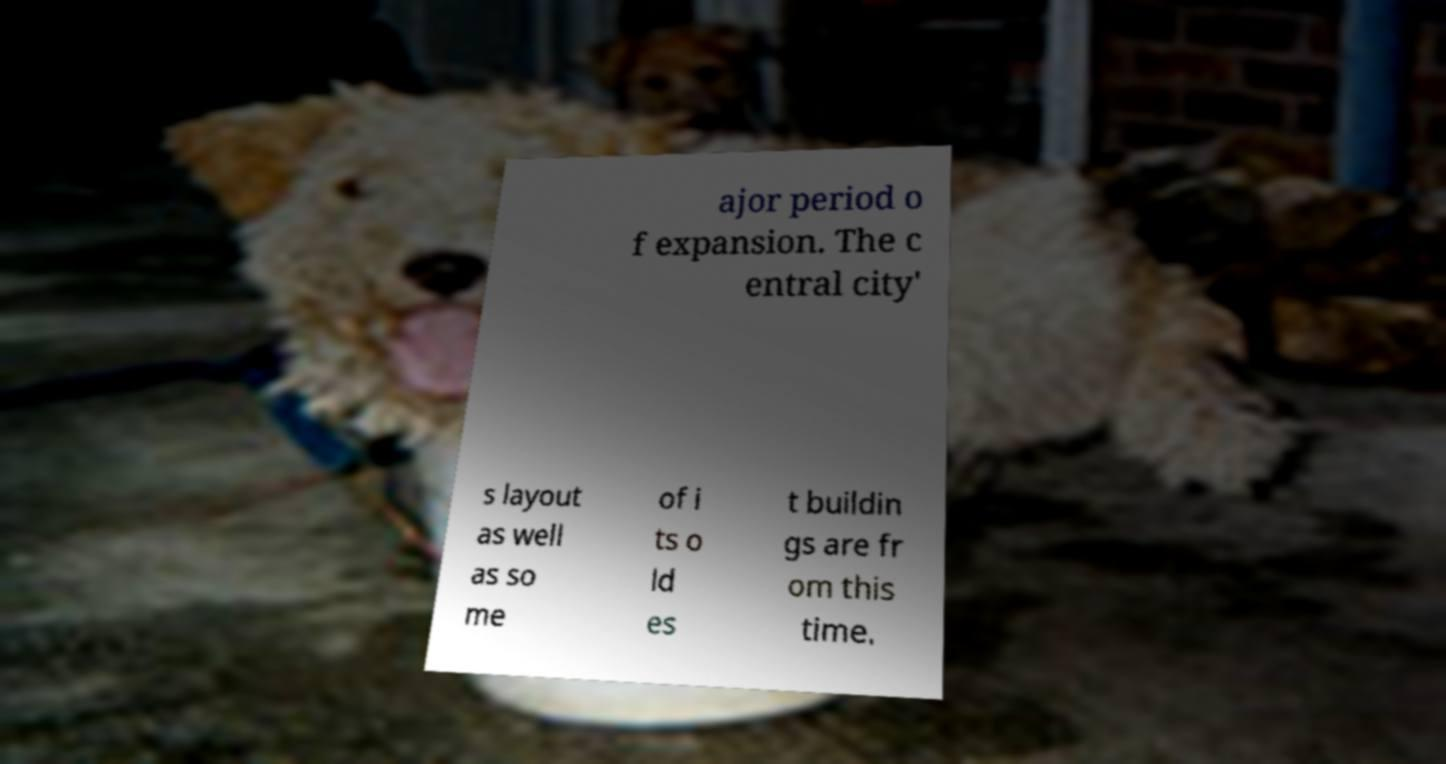For documentation purposes, I need the text within this image transcribed. Could you provide that? ajor period o f expansion. The c entral city' s layout as well as so me of i ts o ld es t buildin gs are fr om this time. 